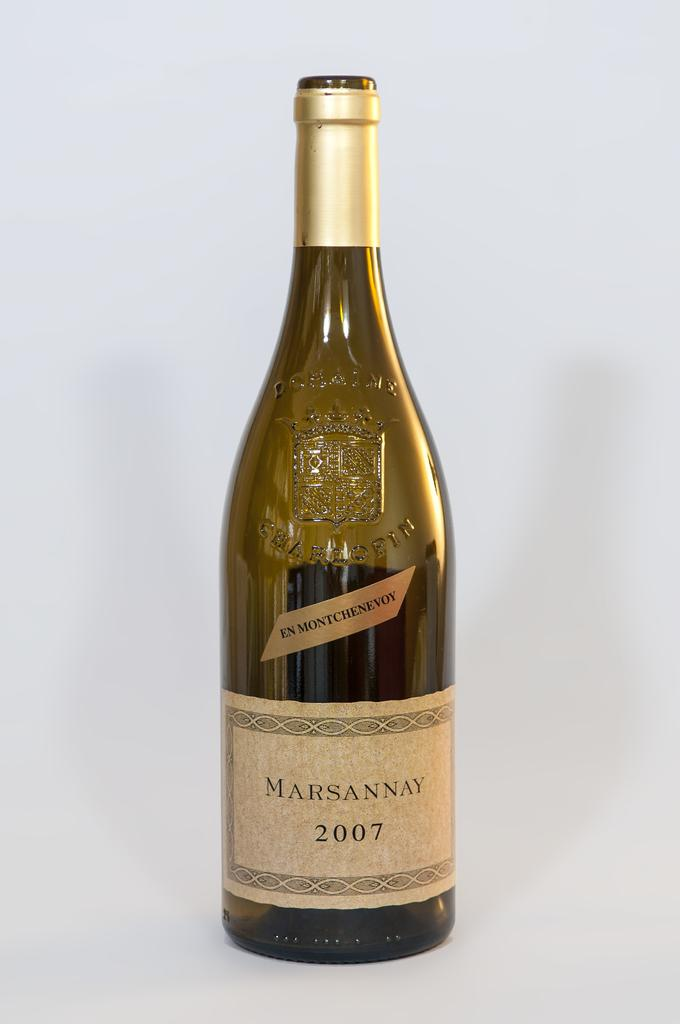<image>
Provide a brief description of the given image. A bottle of wine that has a label on it that says Marsannay on it. 